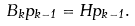<formula> <loc_0><loc_0><loc_500><loc_500>B _ { k } p _ { k - 1 } = H p _ { k - 1 } .</formula> 